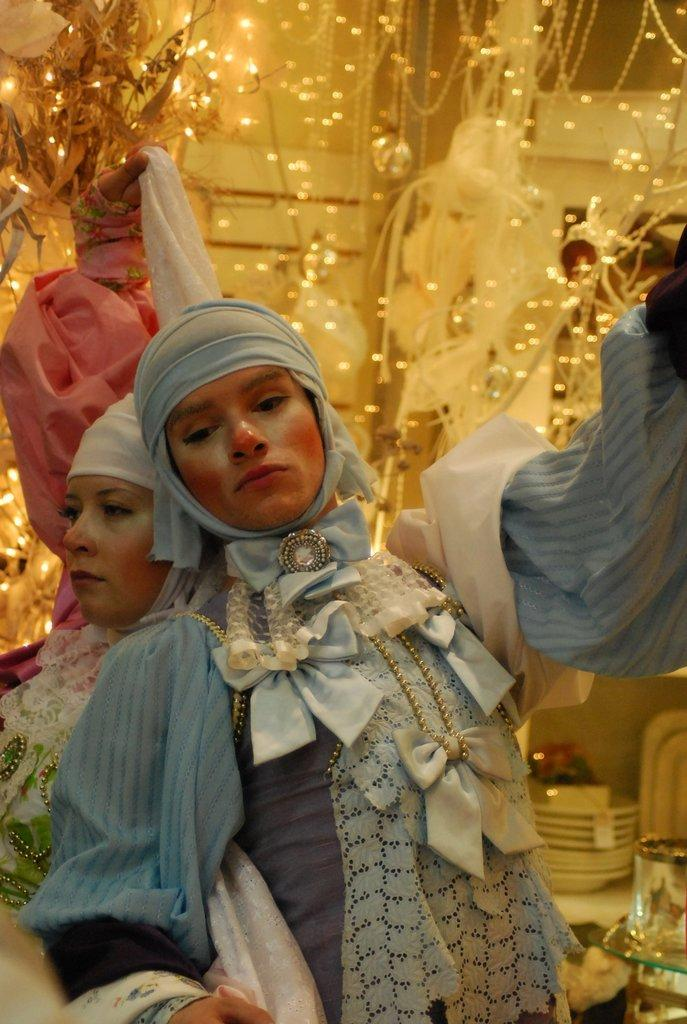What are the two persons in the image doing? The two persons in the image are dancing. What can be seen in the image besides the dancing persons? There is a decoration with lights in the image. What is visible in the background of the image? There is a wall in the background of the image. What type of eggnog is being served at the event in the image? There is no mention of eggnog or any event in the image; it simply shows two persons dancing and a decoration with lights. 